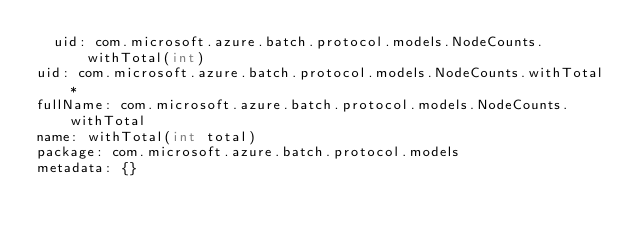<code> <loc_0><loc_0><loc_500><loc_500><_YAML_>  uid: com.microsoft.azure.batch.protocol.models.NodeCounts.withTotal(int)
uid: com.microsoft.azure.batch.protocol.models.NodeCounts.withTotal*
fullName: com.microsoft.azure.batch.protocol.models.NodeCounts.withTotal
name: withTotal(int total)
package: com.microsoft.azure.batch.protocol.models
metadata: {}
</code> 